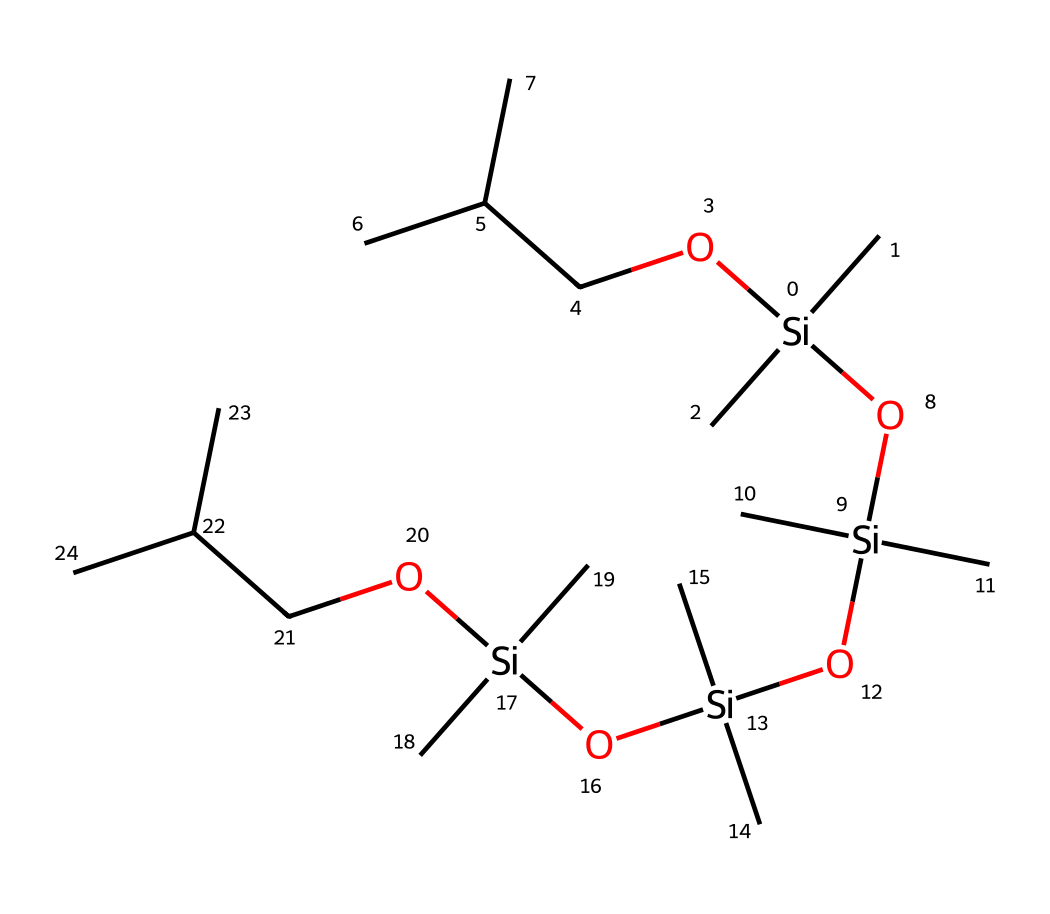what is the central atom in this chemical? The SMILES representation reveals the presence of silicon atoms that are central to the structure, denoted by the 'Si' symbols. This indicates that silicon is the backbone of this silicone-based lubricant.
Answer: silicon how many silicon atoms are present in the structure? By examining the SMILES representation, we can count the occurrences of 'Si', which appears four times in total. Hence, there are four silicon atoms in the chemical structure.
Answer: four what functional groups are evident in this lubricant? In the chemical structure, we can identify hydroxyl groups ('OH'), indicated by 'O[Si]' and occur multiple times. Therefore, we can conclude that the silicone lubricant contains hydroxyl functional groups.
Answer: hydroxyl what kind of lubricant is this based on its structure? Given that the structure prominently features silicon and oxygen atoms, the chemical falls into the category of silicone-based lubricants, which are known for their unique properties such as stability and water resistance.
Answer: silicone-based how many branches does the chemical's structure have? By analyzing the structure, we find that there are multiple branches derived from the central silicon atoms, specifically seen in the 'C' groups connected to each 'Si'. Counting these, we can identify that there are a total of six branches present.
Answer: six does this lubricant contain alkyl groups? The presence of 'C(C)C' parts in the structure indicates the presence of alkyl groups, specifically isopropyl groups (due to the branching), confirming that the lubricant contains such groups.
Answer: yes what property does the presence of the hydroxyl groups impart to this lubricant? Hydroxyl groups contribute to the lubricant's ability to interact with surfaces and may enhance its effectiveness as a moisture barrier, improving adhesion and stability. Therefore, the presence of these groups suggests improved performance characteristics in certain applications.
Answer: moisture barrier 